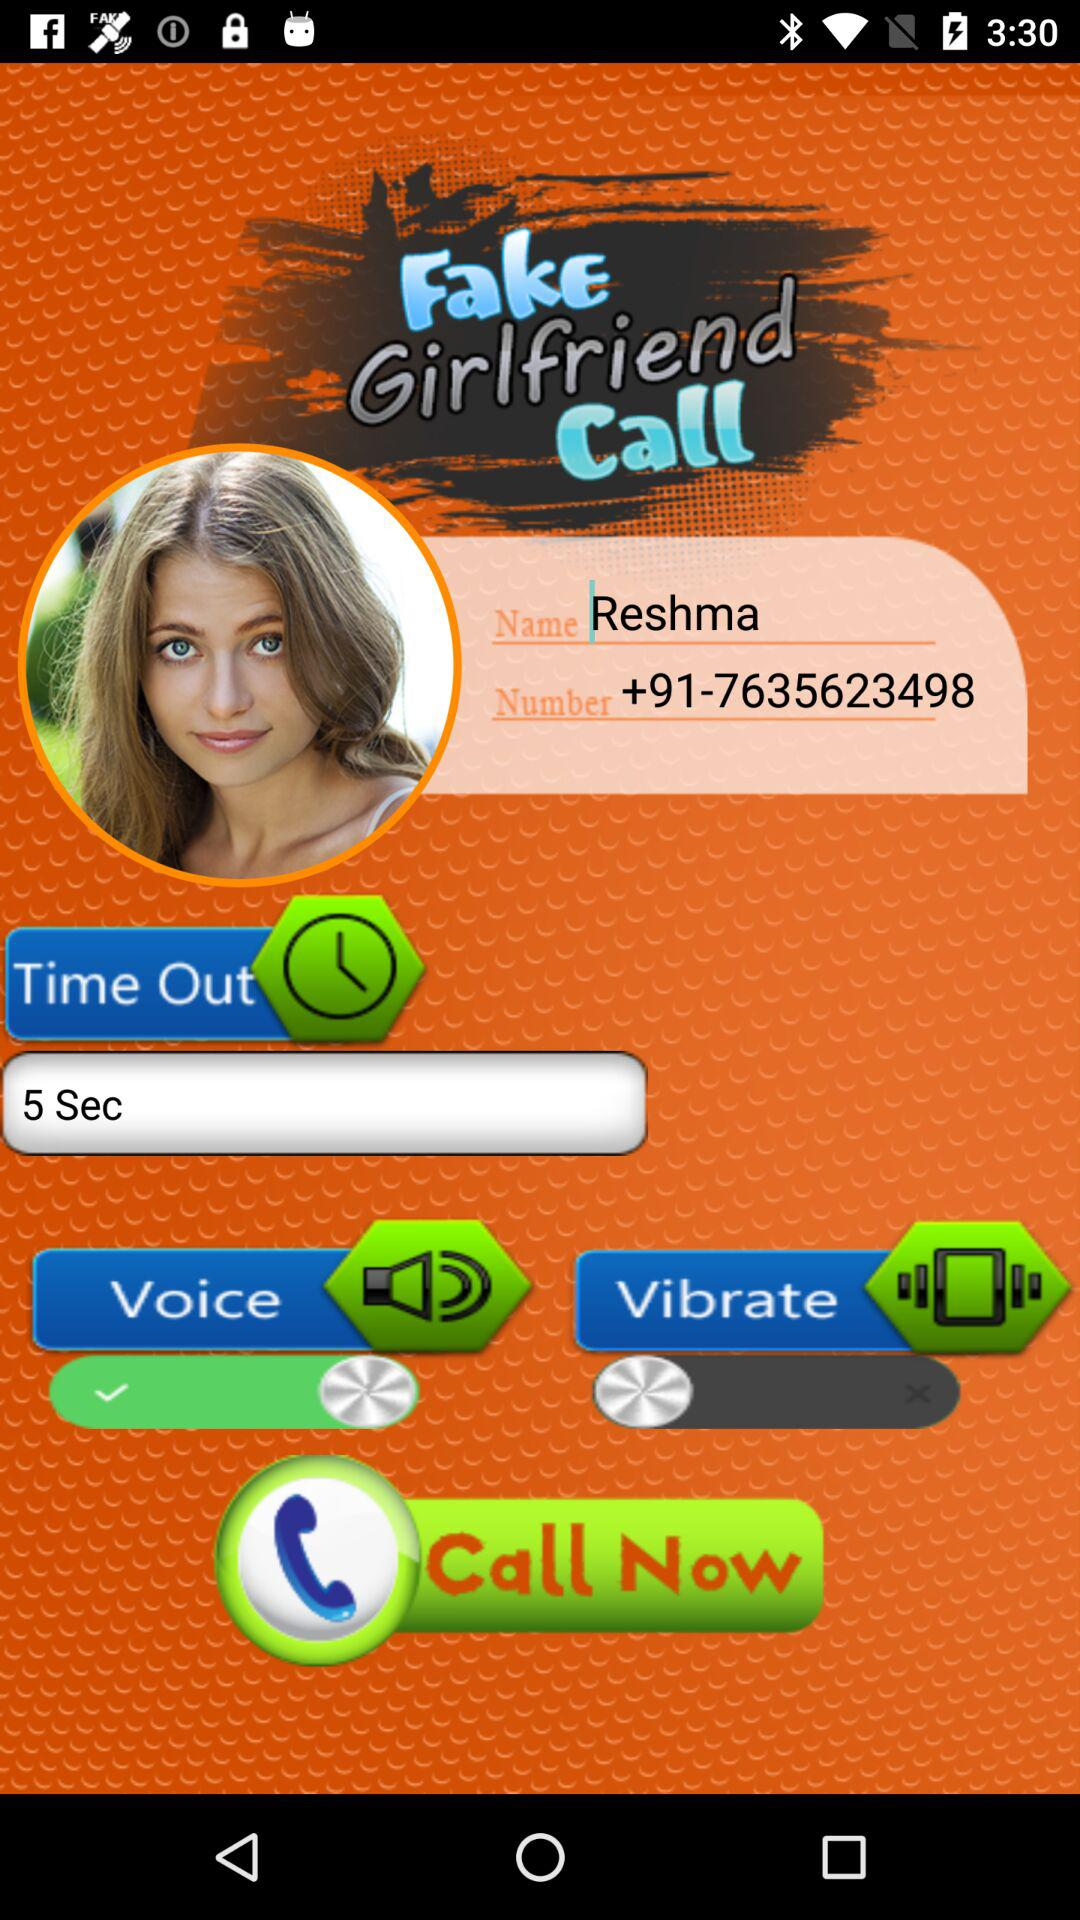What is the mentioned mobile number? The mentioned mobile number is +91-7635623498. 